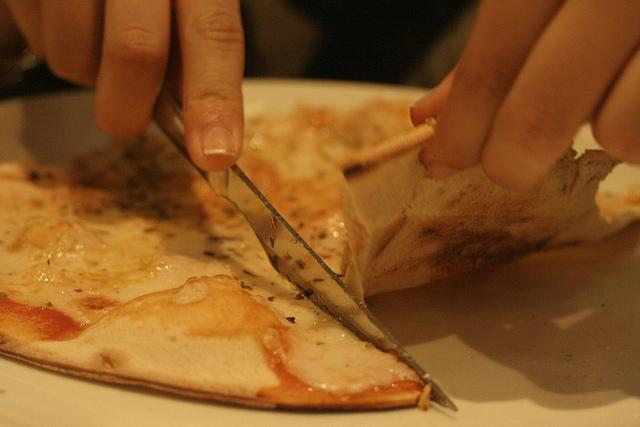What other utensil usually goes alongside the one shown? Please explain your reasoning. fork. The knife is used to cut food into smaller pieces and a fork is used to put those smaller pieces into a mouth. 